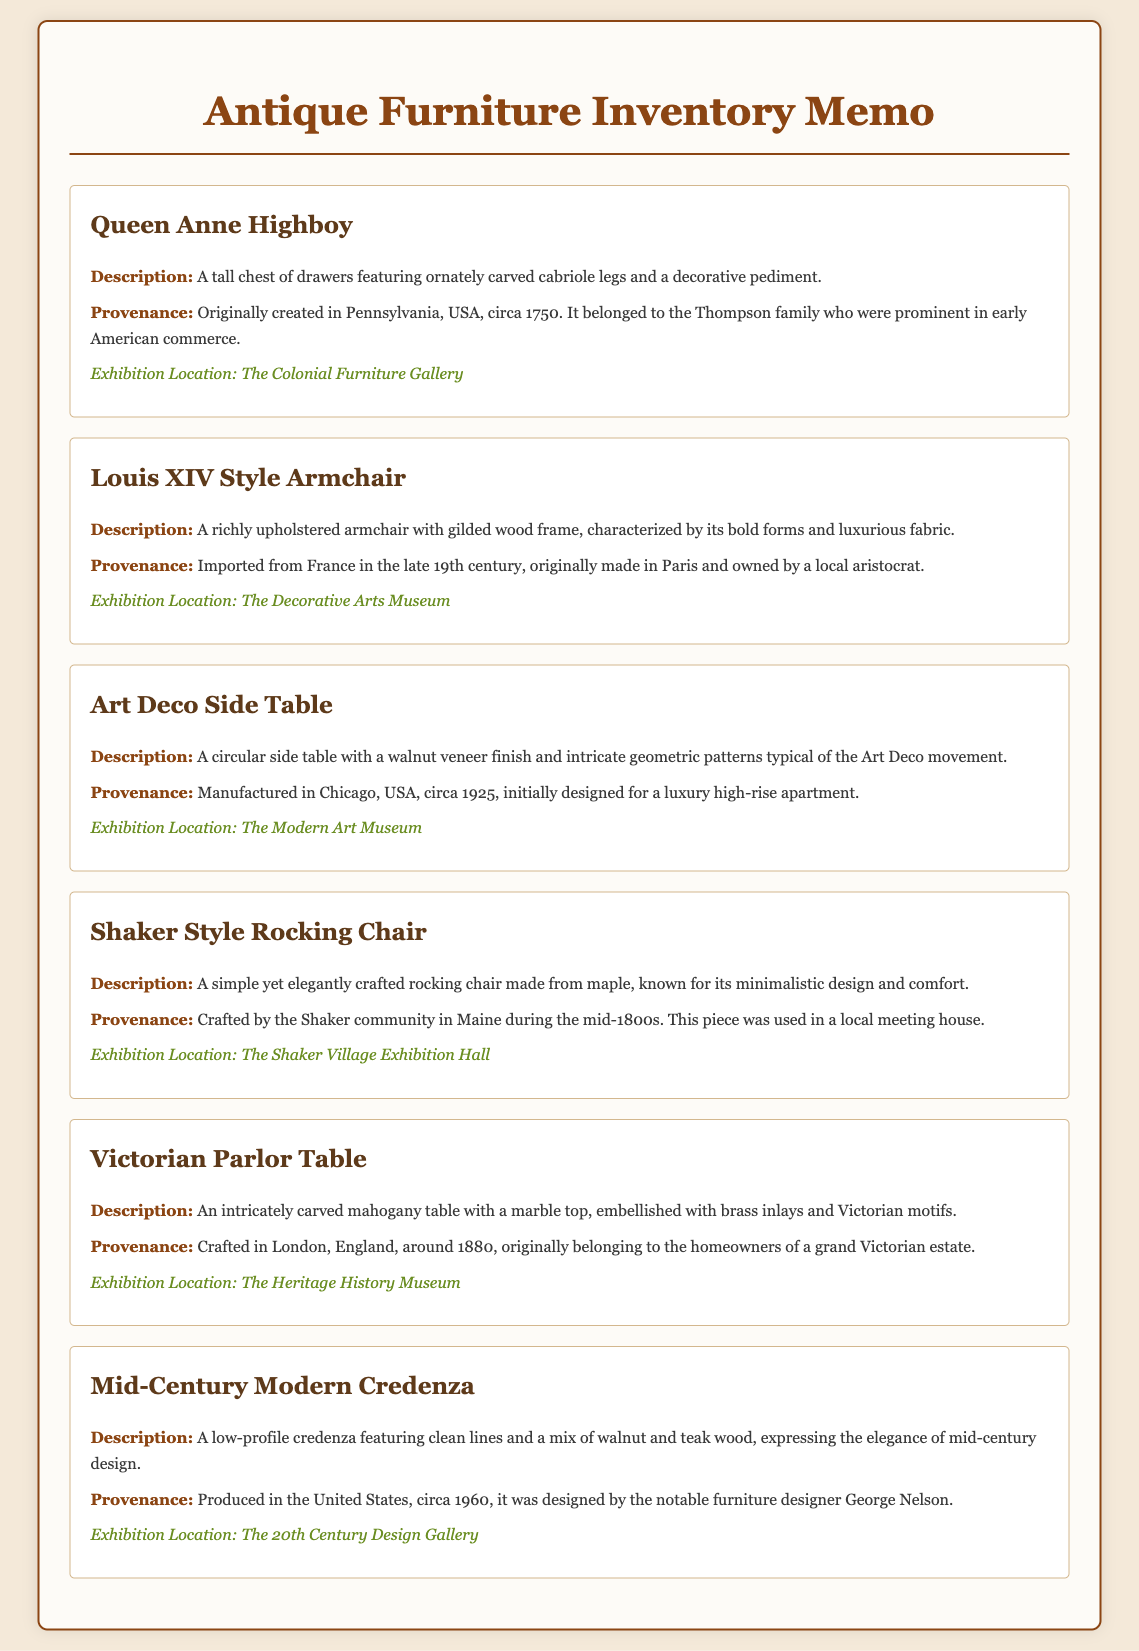What is the first item listed in the inventory? The first item listed is "Queen Anne Highboy."
Answer: Queen Anne Highboy What style is the armchair described in the document? The armchair is described as "Louis XIV Style."
Answer: Louis XIV Style In what year was the Art Deco Side Table manufactured? The Art Deco Side Table was manufactured circa 1925.
Answer: circa 1925 What is the provenance of the Victorian Parlor Table? The provenance states it was crafted in London, England, around 1880.
Answer: London, England, around 1880 Which exhibition location is mentioned for the Shaker Style Rocking Chair? The exhibition location mentioned is "The Shaker Village Exhibition Hall."
Answer: The Shaker Village Exhibition Hall How many items have a provenance related to the United States? There are three items with a provenance related to the United States: Queen Anne Highboy, Art Deco Side Table, and Mid-Century Modern Credenza.
Answer: Three What common material is used for the Mid-Century Modern Credenza? The common material used for the credenza is wood, specifically walnut and teak.
Answer: Walnut and teak Which item is associated with a local aristocrat? The item associated with a local aristocrat is "Louis XIV Style Armchair."
Answer: Louis XIV Style Armchair What is the color of the text in the h1 heading? The color of the text in the h1 heading is "#8b4513."
Answer: #8b4513 